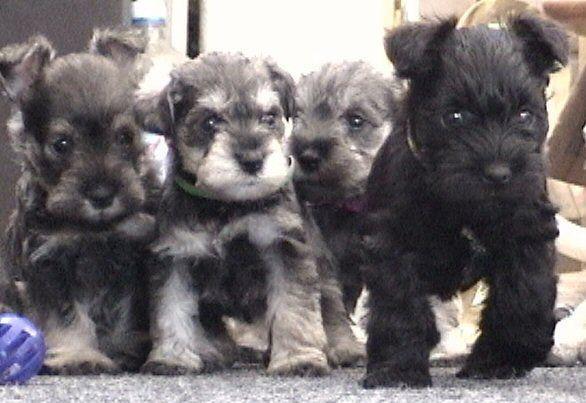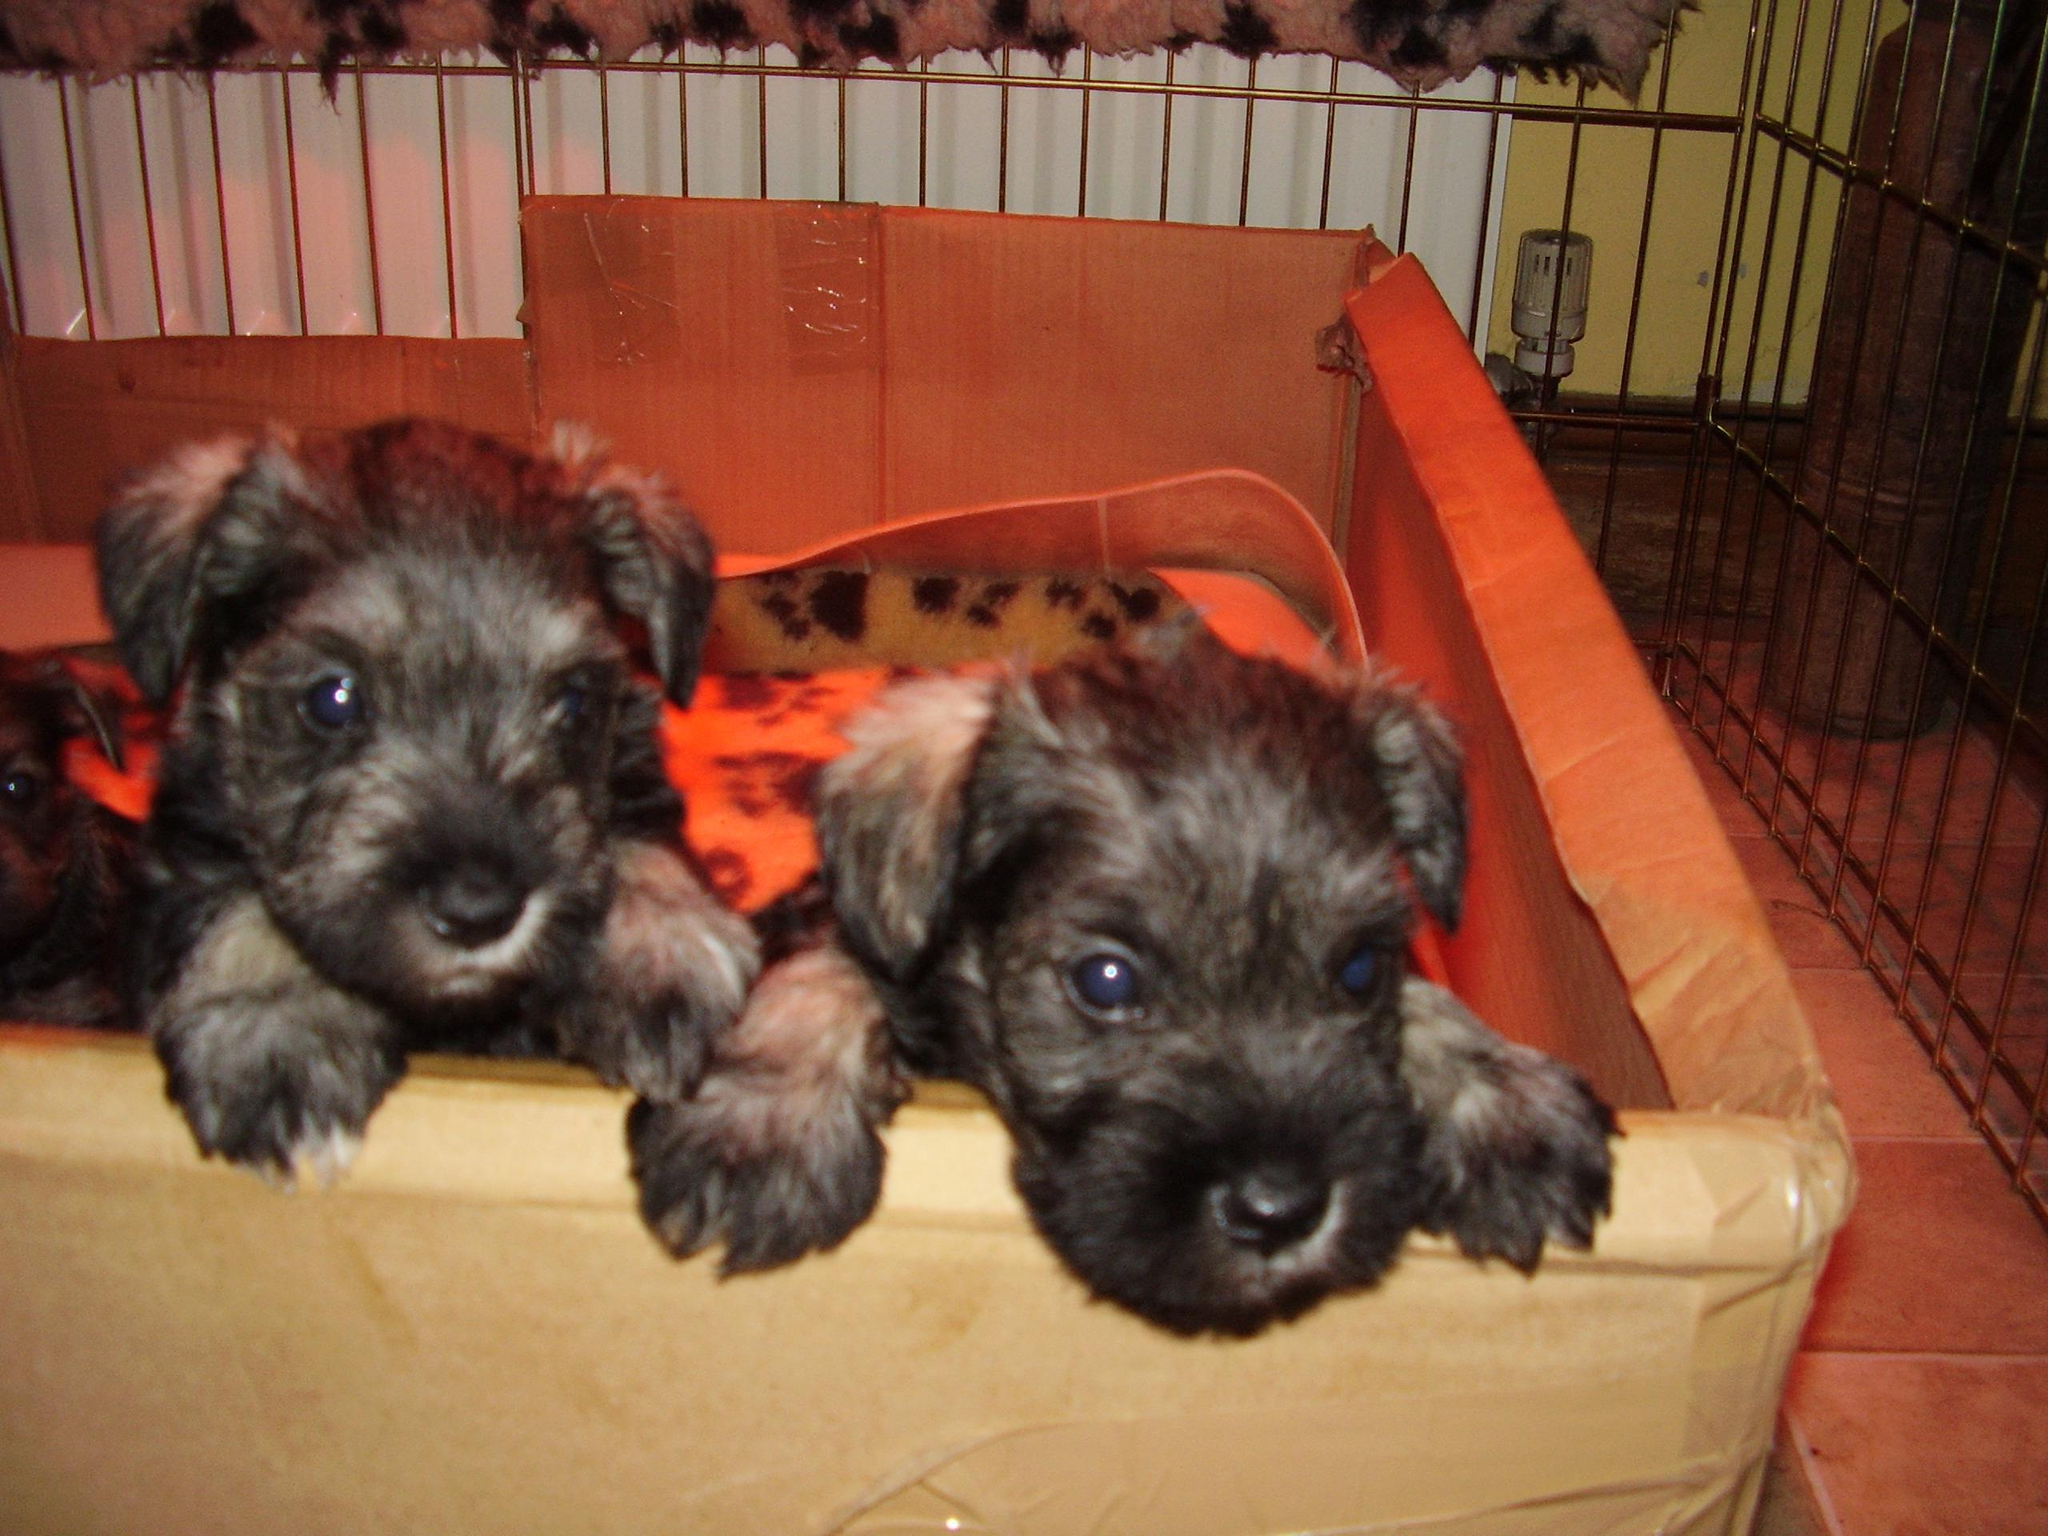The first image is the image on the left, the second image is the image on the right. Examine the images to the left and right. Is the description "there are puppies in a wooden box" accurate? Answer yes or no. Yes. The first image is the image on the left, the second image is the image on the right. Considering the images on both sides, is "At least one puppy has white hair around it's mouth." valid? Answer yes or no. Yes. 